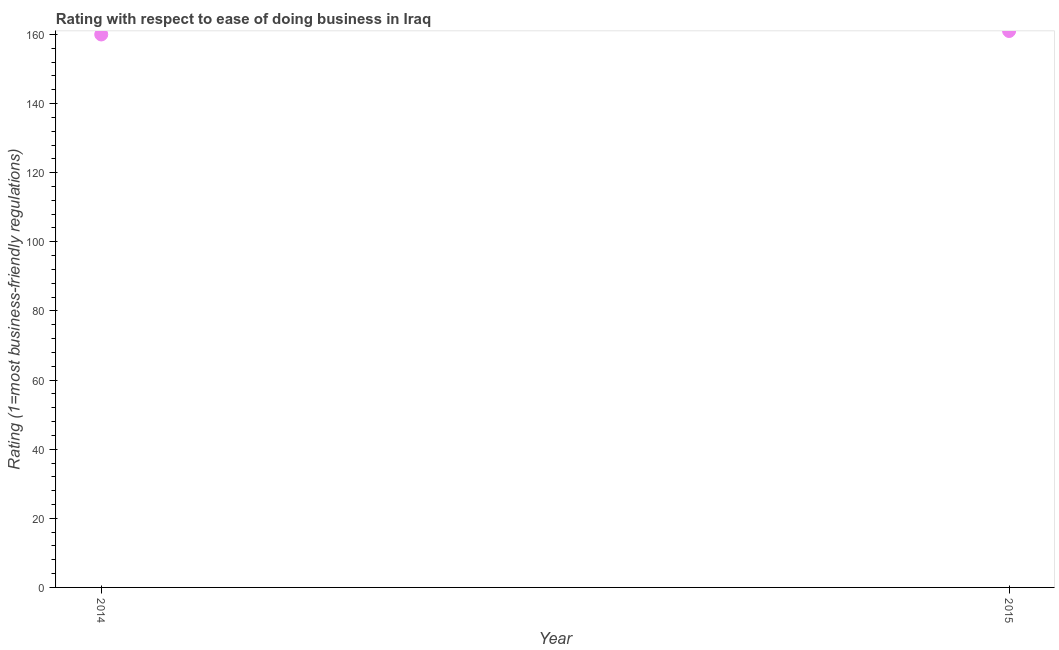What is the ease of doing business index in 2015?
Offer a terse response. 161. Across all years, what is the maximum ease of doing business index?
Give a very brief answer. 161. Across all years, what is the minimum ease of doing business index?
Your answer should be very brief. 160. In which year was the ease of doing business index maximum?
Make the answer very short. 2015. What is the sum of the ease of doing business index?
Your answer should be compact. 321. What is the difference between the ease of doing business index in 2014 and 2015?
Your response must be concise. -1. What is the average ease of doing business index per year?
Provide a succinct answer. 160.5. What is the median ease of doing business index?
Offer a terse response. 160.5. In how many years, is the ease of doing business index greater than 120 ?
Provide a succinct answer. 2. What is the ratio of the ease of doing business index in 2014 to that in 2015?
Your answer should be compact. 0.99. Is the ease of doing business index in 2014 less than that in 2015?
Provide a short and direct response. Yes. In how many years, is the ease of doing business index greater than the average ease of doing business index taken over all years?
Keep it short and to the point. 1. Does the graph contain any zero values?
Offer a terse response. No. Does the graph contain grids?
Provide a succinct answer. No. What is the title of the graph?
Make the answer very short. Rating with respect to ease of doing business in Iraq. What is the label or title of the Y-axis?
Your answer should be very brief. Rating (1=most business-friendly regulations). What is the Rating (1=most business-friendly regulations) in 2014?
Your answer should be very brief. 160. What is the Rating (1=most business-friendly regulations) in 2015?
Provide a succinct answer. 161. What is the ratio of the Rating (1=most business-friendly regulations) in 2014 to that in 2015?
Ensure brevity in your answer.  0.99. 